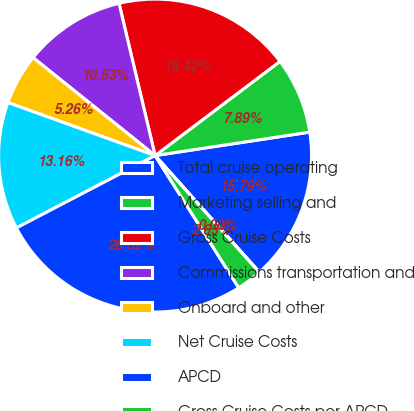Convert chart. <chart><loc_0><loc_0><loc_500><loc_500><pie_chart><fcel>Total cruise operating<fcel>Marketing selling and<fcel>Gross Cruise Costs<fcel>Commissions transportation and<fcel>Onboard and other<fcel>Net Cruise Costs<fcel>APCD<fcel>Gross Cruise Costs per APCD<fcel>Net Cruise Costs per APCD<nl><fcel>15.79%<fcel>7.89%<fcel>18.42%<fcel>10.53%<fcel>5.26%<fcel>13.16%<fcel>26.32%<fcel>2.63%<fcel>0.0%<nl></chart> 